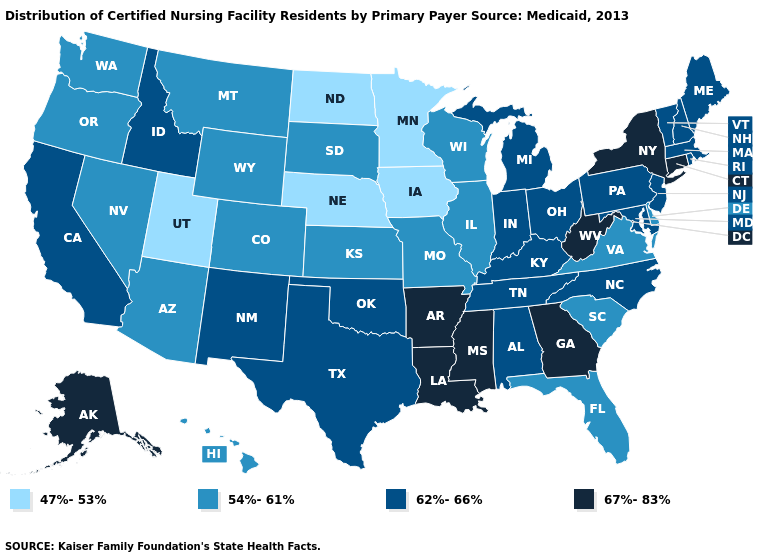Does Colorado have the same value as Kansas?
Concise answer only. Yes. What is the value of Alaska?
Give a very brief answer. 67%-83%. Name the states that have a value in the range 62%-66%?
Be succinct. Alabama, California, Idaho, Indiana, Kentucky, Maine, Maryland, Massachusetts, Michigan, New Hampshire, New Jersey, New Mexico, North Carolina, Ohio, Oklahoma, Pennsylvania, Rhode Island, Tennessee, Texas, Vermont. What is the value of Arizona?
Concise answer only. 54%-61%. Which states hav the highest value in the South?
Answer briefly. Arkansas, Georgia, Louisiana, Mississippi, West Virginia. Is the legend a continuous bar?
Keep it brief. No. Does Connecticut have a higher value than New Mexico?
Concise answer only. Yes. Name the states that have a value in the range 54%-61%?
Answer briefly. Arizona, Colorado, Delaware, Florida, Hawaii, Illinois, Kansas, Missouri, Montana, Nevada, Oregon, South Carolina, South Dakota, Virginia, Washington, Wisconsin, Wyoming. Name the states that have a value in the range 54%-61%?
Quick response, please. Arizona, Colorado, Delaware, Florida, Hawaii, Illinois, Kansas, Missouri, Montana, Nevada, Oregon, South Carolina, South Dakota, Virginia, Washington, Wisconsin, Wyoming. What is the value of Iowa?
Give a very brief answer. 47%-53%. What is the value of California?
Be succinct. 62%-66%. Which states have the highest value in the USA?
Short answer required. Alaska, Arkansas, Connecticut, Georgia, Louisiana, Mississippi, New York, West Virginia. Does Alabama have the highest value in the USA?
Concise answer only. No. What is the lowest value in the USA?
Write a very short answer. 47%-53%. Does North Dakota have the lowest value in the USA?
Answer briefly. Yes. 